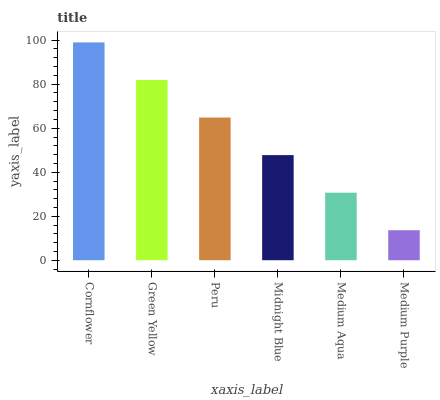Is Medium Purple the minimum?
Answer yes or no. Yes. Is Cornflower the maximum?
Answer yes or no. Yes. Is Green Yellow the minimum?
Answer yes or no. No. Is Green Yellow the maximum?
Answer yes or no. No. Is Cornflower greater than Green Yellow?
Answer yes or no. Yes. Is Green Yellow less than Cornflower?
Answer yes or no. Yes. Is Green Yellow greater than Cornflower?
Answer yes or no. No. Is Cornflower less than Green Yellow?
Answer yes or no. No. Is Peru the high median?
Answer yes or no. Yes. Is Midnight Blue the low median?
Answer yes or no. Yes. Is Cornflower the high median?
Answer yes or no. No. Is Medium Purple the low median?
Answer yes or no. No. 